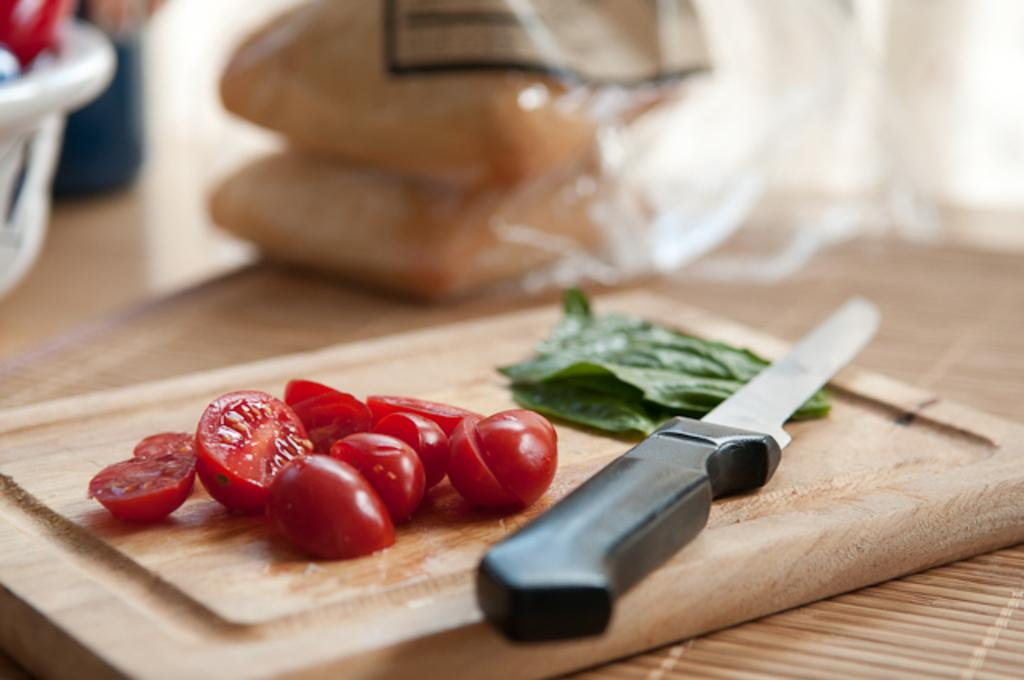What type of food items can be seen in the front of the image? There are vegetables in the front of the image. What tool is visible on a chopping board in the image? There is a knife on a chopping board in the image. Can you describe the objects in the background of the image? The objects in the background of the image are blurry. What type of pail can be seen in the image? There is no pail present in the image. Can you hear any coughing sounds in the image? The image is silent, and there are no sounds or audible cues present. 